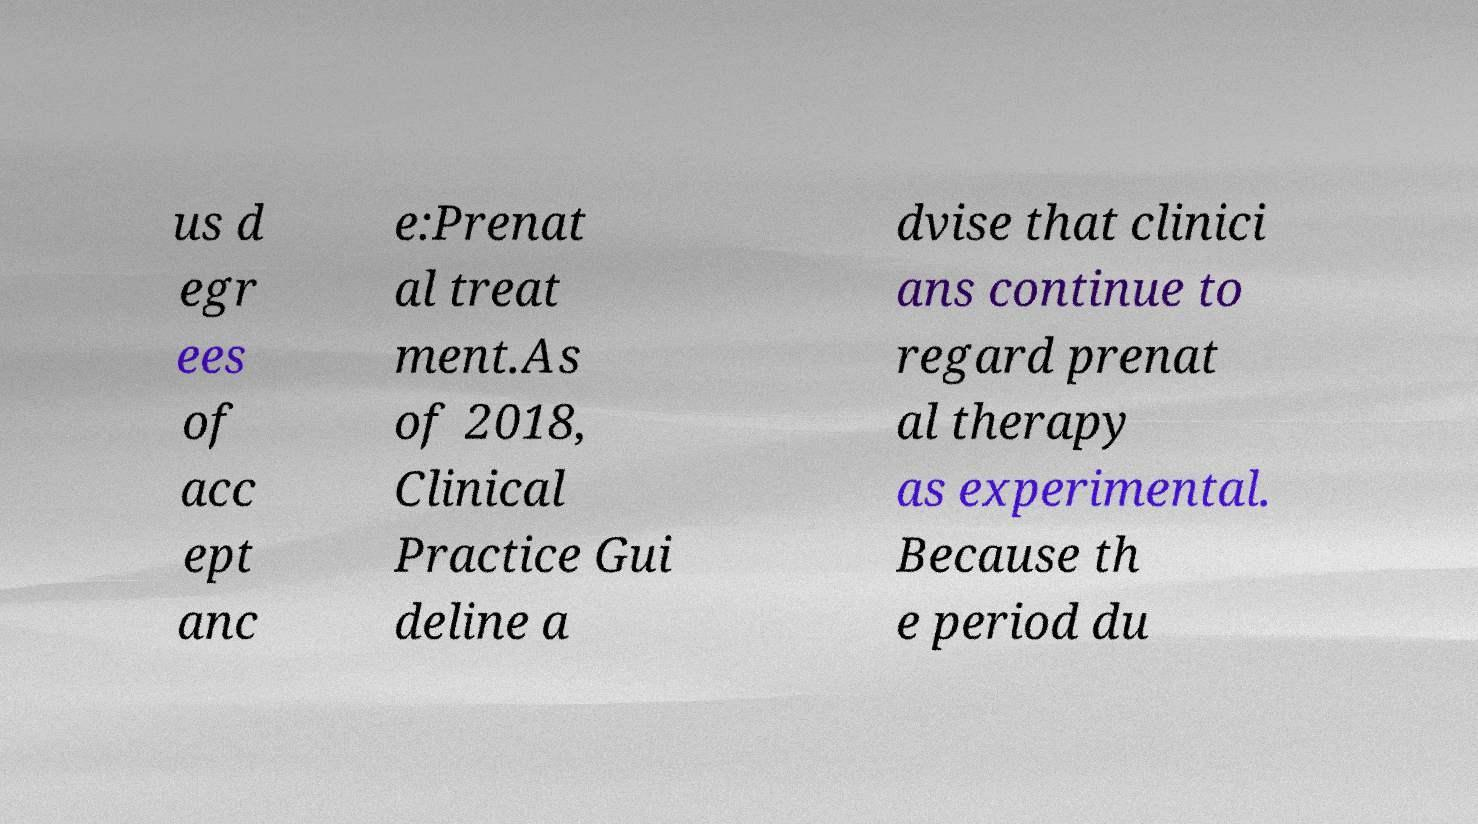Can you read and provide the text displayed in the image?This photo seems to have some interesting text. Can you extract and type it out for me? us d egr ees of acc ept anc e:Prenat al treat ment.As of 2018, Clinical Practice Gui deline a dvise that clinici ans continue to regard prenat al therapy as experimental. Because th e period du 